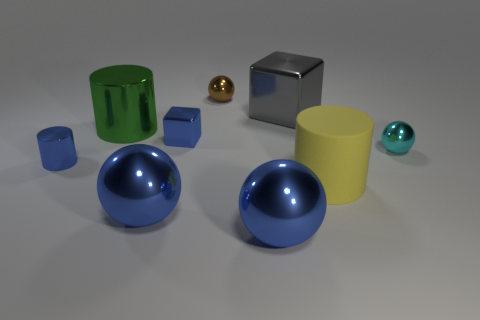The metal cylinder that is behind the small object that is right of the tiny brown metallic thing is what color?
Your answer should be compact. Green. There is a cube that is the same size as the blue metal cylinder; what is its color?
Provide a short and direct response. Blue. How many big shiny objects are both to the right of the blue shiny block and in front of the cyan ball?
Your response must be concise. 1. There is a tiny shiny thing that is the same color as the small cylinder; what shape is it?
Give a very brief answer. Cube. There is a cylinder that is both behind the rubber cylinder and on the right side of the tiny blue shiny cylinder; what is its material?
Ensure brevity in your answer.  Metal. Are there fewer gray shiny objects in front of the small metal block than metallic cylinders on the left side of the big green metallic cylinder?
Give a very brief answer. Yes. There is a brown sphere that is made of the same material as the tiny cube; what is its size?
Provide a short and direct response. Small. Is there any other thing that is the same color as the tiny cylinder?
Ensure brevity in your answer.  Yes. Is the material of the small brown object the same as the cylinder that is in front of the small blue metallic cylinder?
Make the answer very short. No. There is another large object that is the same shape as the green thing; what is it made of?
Your answer should be compact. Rubber. 